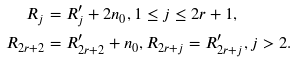<formula> <loc_0><loc_0><loc_500><loc_500>R _ { j } & = R _ { j } ^ { \prime } + 2 n _ { 0 } , 1 \leq j \leq 2 r + 1 , \\ R _ { 2 r + 2 } & = R _ { 2 r + 2 } ^ { \prime } + n _ { 0 } , R _ { 2 r + j } = R _ { 2 r + j } ^ { \prime } , j > 2 .</formula> 